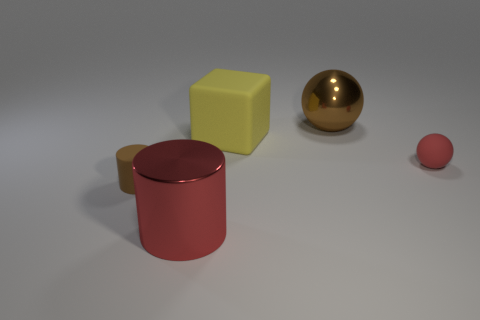How many small balls are the same color as the large block?
Provide a short and direct response. 0. Is the large matte thing the same color as the rubber cylinder?
Provide a short and direct response. No. What number of other large things have the same material as the yellow thing?
Offer a terse response. 0. Does the rubber object that is to the left of the red metallic cylinder have the same size as the yellow cube?
Keep it short and to the point. No. The metallic sphere that is the same size as the yellow matte cube is what color?
Give a very brief answer. Brown. How many rubber balls are to the left of the large rubber object?
Your answer should be very brief. 0. Are any large gray objects visible?
Your answer should be very brief. No. There is a metallic object that is in front of the ball that is behind the small matte thing right of the large red metal object; what is its size?
Give a very brief answer. Large. How many other things are the same size as the red sphere?
Give a very brief answer. 1. What size is the red object that is in front of the matte ball?
Offer a very short reply. Large. 